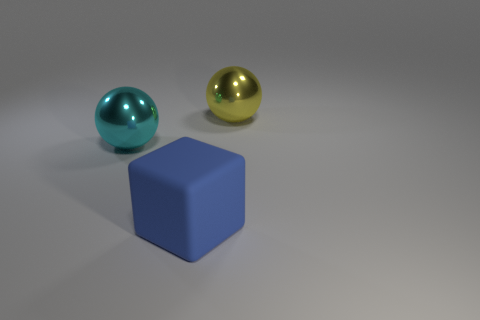Are there any other things that have the same material as the blue thing?
Provide a short and direct response. No. There is a large shiny thing that is to the right of the matte object; what is its shape?
Offer a very short reply. Sphere. There is a shiny ball that is in front of the big metal object to the right of the block; are there any big blue rubber blocks right of it?
Ensure brevity in your answer.  Yes. Is there any other thing that has the same shape as the large blue matte thing?
Provide a short and direct response. No. Are any large yellow spheres visible?
Your answer should be compact. Yes. Is the big object right of the large blue cube made of the same material as the big object that is in front of the cyan sphere?
Your answer should be compact. No. There is a shiny sphere behind the sphere in front of the metal sphere that is to the right of the cyan metallic ball; what is its size?
Offer a terse response. Large. How many big yellow spheres are the same material as the blue block?
Give a very brief answer. 0. Is the number of large blue rubber blocks less than the number of red shiny cylinders?
Offer a terse response. No. Do the large ball behind the cyan metallic sphere and the cyan object have the same material?
Offer a terse response. Yes. 